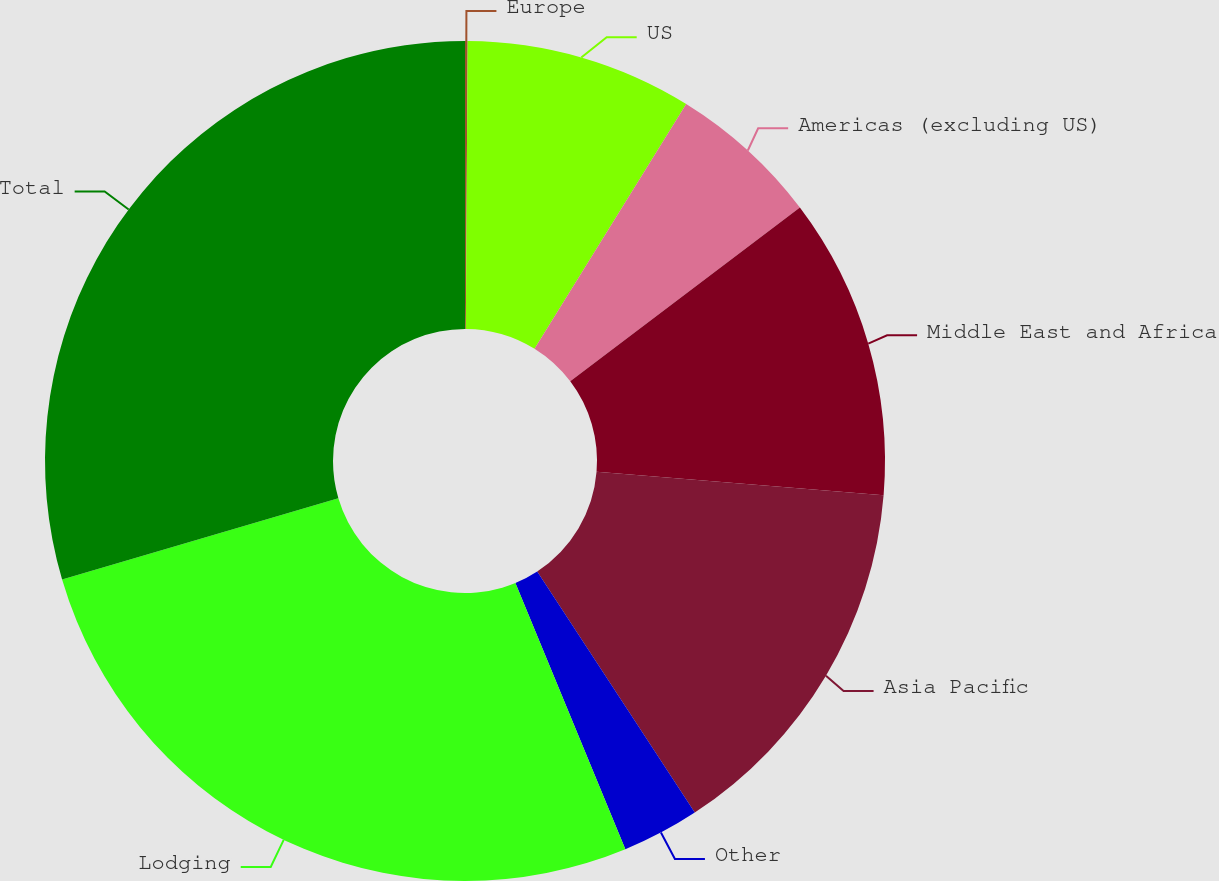Convert chart. <chart><loc_0><loc_0><loc_500><loc_500><pie_chart><fcel>Europe<fcel>US<fcel>Americas (excluding US)<fcel>Middle East and Africa<fcel>Asia Pacific<fcel>Other<fcel>Lodging<fcel>Total<nl><fcel>0.1%<fcel>8.73%<fcel>5.86%<fcel>11.61%<fcel>14.49%<fcel>2.98%<fcel>26.68%<fcel>29.56%<nl></chart> 